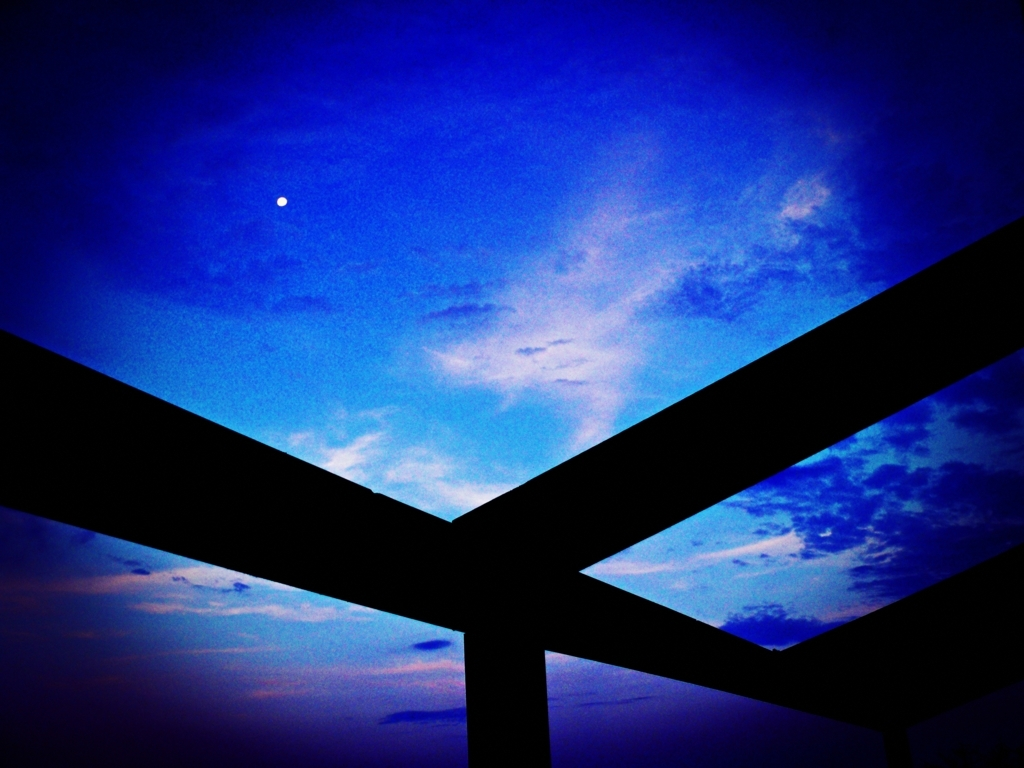What feelings does the composition of this image evoke? The image evokes a sense of tranquility and introspection. The expansive sky, divided by the stark silhouettes of the geometric shapes, creates a kind of window effect, prompting contemplation about the vastness above and beyond. The simplicity of the elements invites the viewer to dwell on thoughts of serenity and the subtle wonders of the natural world as day turns to night. 